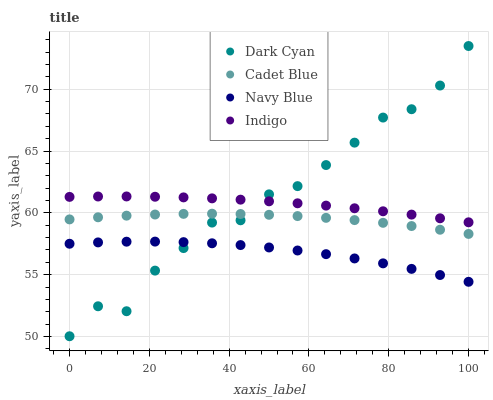Does Navy Blue have the minimum area under the curve?
Answer yes or no. Yes. Does Dark Cyan have the maximum area under the curve?
Answer yes or no. Yes. Does Cadet Blue have the minimum area under the curve?
Answer yes or no. No. Does Cadet Blue have the maximum area under the curve?
Answer yes or no. No. Is Indigo the smoothest?
Answer yes or no. Yes. Is Dark Cyan the roughest?
Answer yes or no. Yes. Is Navy Blue the smoothest?
Answer yes or no. No. Is Navy Blue the roughest?
Answer yes or no. No. Does Dark Cyan have the lowest value?
Answer yes or no. Yes. Does Navy Blue have the lowest value?
Answer yes or no. No. Does Dark Cyan have the highest value?
Answer yes or no. Yes. Does Cadet Blue have the highest value?
Answer yes or no. No. Is Navy Blue less than Indigo?
Answer yes or no. Yes. Is Indigo greater than Navy Blue?
Answer yes or no. Yes. Does Dark Cyan intersect Indigo?
Answer yes or no. Yes. Is Dark Cyan less than Indigo?
Answer yes or no. No. Is Dark Cyan greater than Indigo?
Answer yes or no. No. Does Navy Blue intersect Indigo?
Answer yes or no. No. 